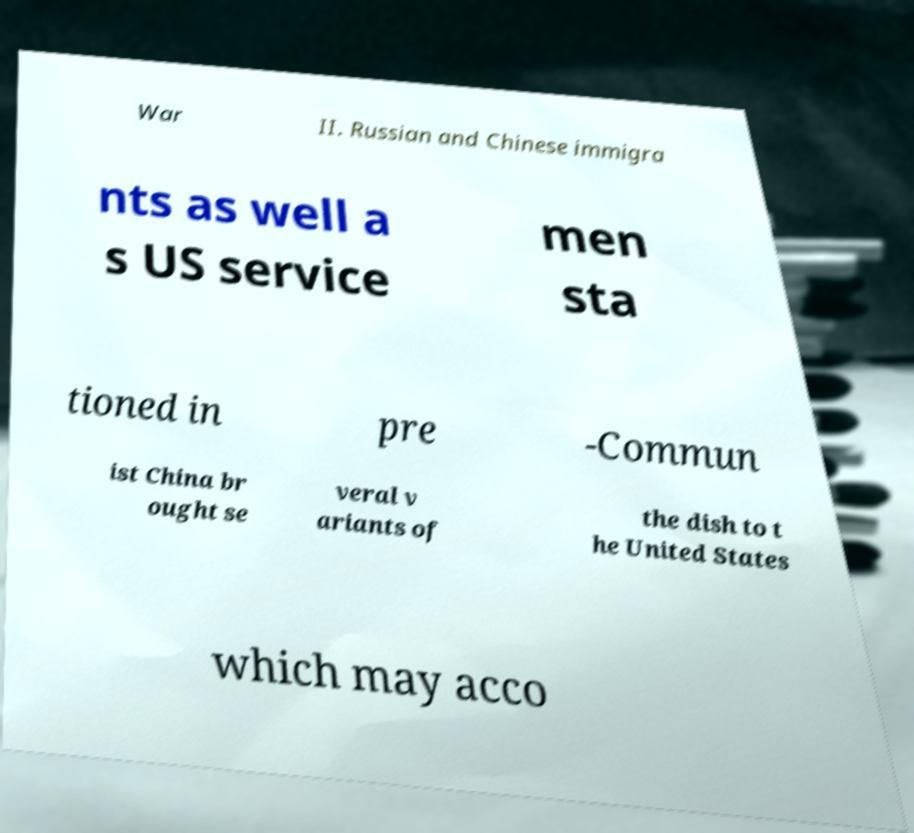Please identify and transcribe the text found in this image. War II. Russian and Chinese immigra nts as well a s US service men sta tioned in pre -Commun ist China br ought se veral v ariants of the dish to t he United States which may acco 